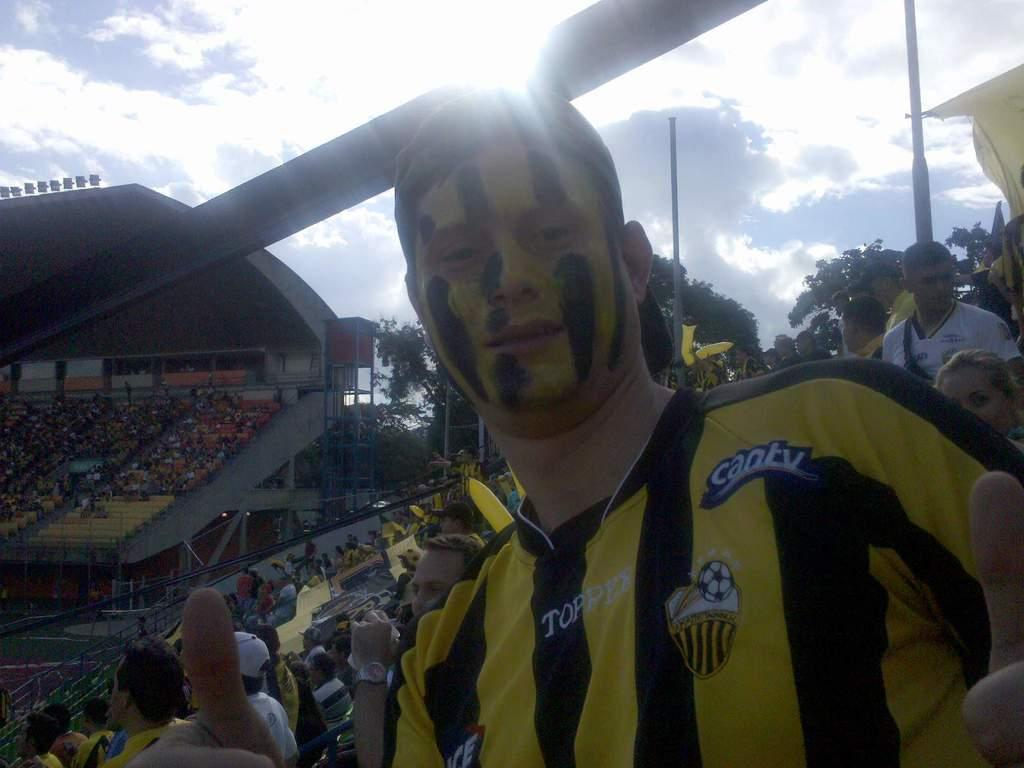<image>
Relay a brief, clear account of the picture shown. A soccer fan wearing a black and yellow striped soccer jersey sitting in a stadium full of people. 